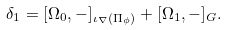Convert formula to latex. <formula><loc_0><loc_0><loc_500><loc_500>\delta _ { 1 } = [ \Omega _ { 0 } , - ] _ { \iota _ { \nabla } ( \Pi _ { \phi } ) } + [ \Omega _ { 1 } , - ] _ { G } .</formula> 